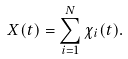Convert formula to latex. <formula><loc_0><loc_0><loc_500><loc_500>X ( t ) = \sum _ { i = 1 } ^ { N } \chi _ { i } ( t ) .</formula> 